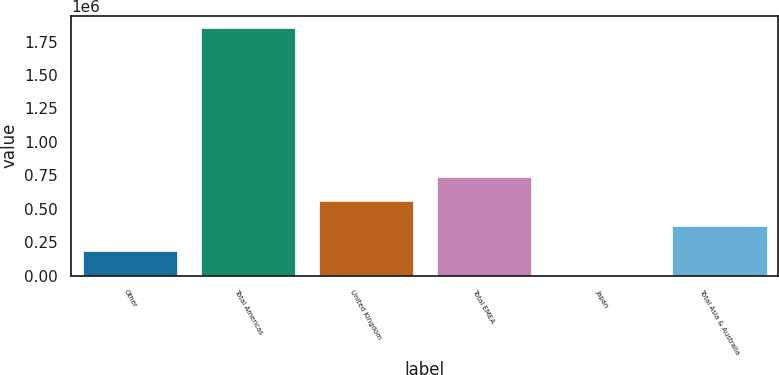Convert chart. <chart><loc_0><loc_0><loc_500><loc_500><bar_chart><fcel>Other<fcel>Total Americas<fcel>United Kingdom<fcel>Total EMEA<fcel>Japan<fcel>Total Asia & Australia<nl><fcel>185318<fcel>1.84929e+06<fcel>555089<fcel>739975<fcel>432<fcel>370204<nl></chart> 